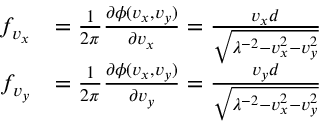<formula> <loc_0><loc_0><loc_500><loc_500>\begin{array} { r l } { f _ { v _ { x } } } & { = \frac { 1 } { 2 \pi } \frac { \partial \phi ( v _ { x } , v _ { y } ) } { \partial v _ { x } } = \frac { v _ { x } d } { \sqrt { \lambda ^ { - 2 } - v _ { x } ^ { 2 } - v _ { y } ^ { 2 } } } } \\ { f _ { v _ { y } } } & { = \frac { 1 } { 2 \pi } \frac { \partial \phi ( v _ { x } , v _ { y } ) } { \partial v _ { y } } = \frac { v _ { y } d } { \sqrt { \lambda ^ { - 2 } - v _ { x } ^ { 2 } - v _ { y } ^ { 2 } } } } \end{array}</formula> 